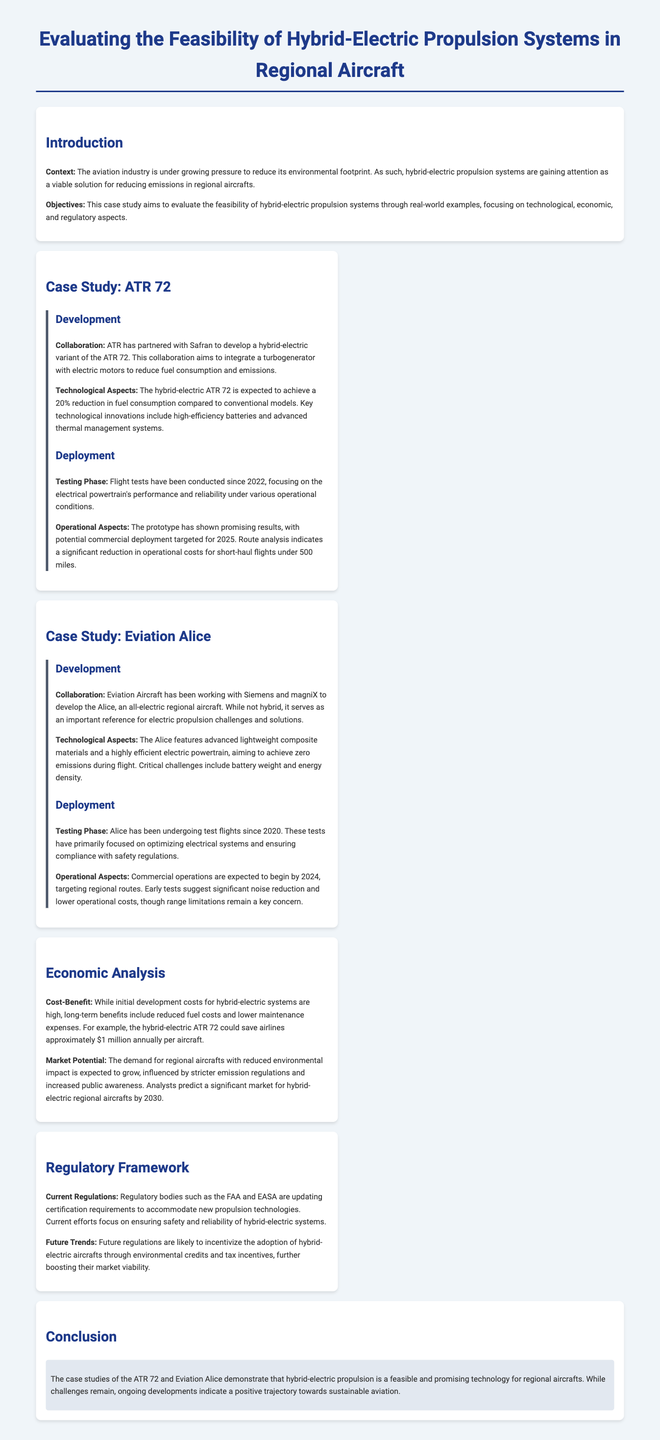What is the primary goal of the case study? The primary goal of the case study is to evaluate the feasibility of hybrid-electric propulsion systems through real-world examples.
Answer: Evaluate the feasibility of hybrid-electric propulsion systems Who is the partner of ATR in developing the hybrid-electric ATR 72? ATR has partnered with Safran to develop a hybrid-electric variant of the ATR 72.
Answer: Safran What percentage reduction in fuel consumption does the hybrid-electric ATR 72 aim to achieve? The hybrid-electric ATR 72 is expected to achieve a 20% reduction in fuel consumption compared to conventional models.
Answer: 20% When did testing for the Eviation Alice begin? Alice has been undergoing test flights since 2020.
Answer: 2020 What is the expected commercial operation start year for the Eviation Alice? Commercial operations are expected to begin by 2024.
Answer: 2024 How much can the hybrid-electric ATR 72 save airlines annually per aircraft? The hybrid-electric ATR 72 could save airlines approximately $1 million annually per aircraft.
Answer: $1 million What are regulatory bodies currently focused on regarding hybrid-electric systems? Regulatory bodies are updating certification requirements to accommodate new propulsion technologies.
Answer: Certification requirements What environmental benefits are predicted by 2030 for hybrid-electric regional aircraft? Analysts predict a significant market for hybrid-electric regional aircrafts by 2030.
Answer: Significant market What trend is likely to influence future regulations for hybrid-electric aircraft? Future regulations are likely to incentivize the adoption of hybrid-electric aircrafts through environmental credits and tax incentives.
Answer: Incentives through environmental credits 